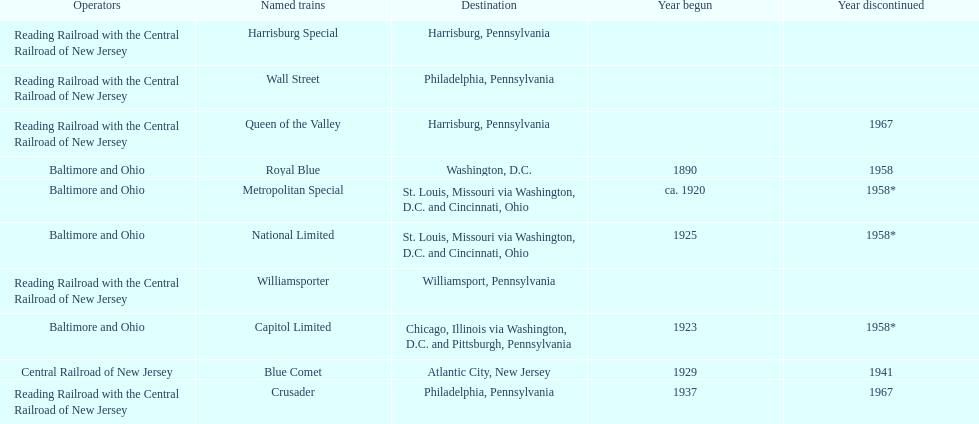What is the difference (in years) between when the royal blue began and the year the crusader began? 47. 